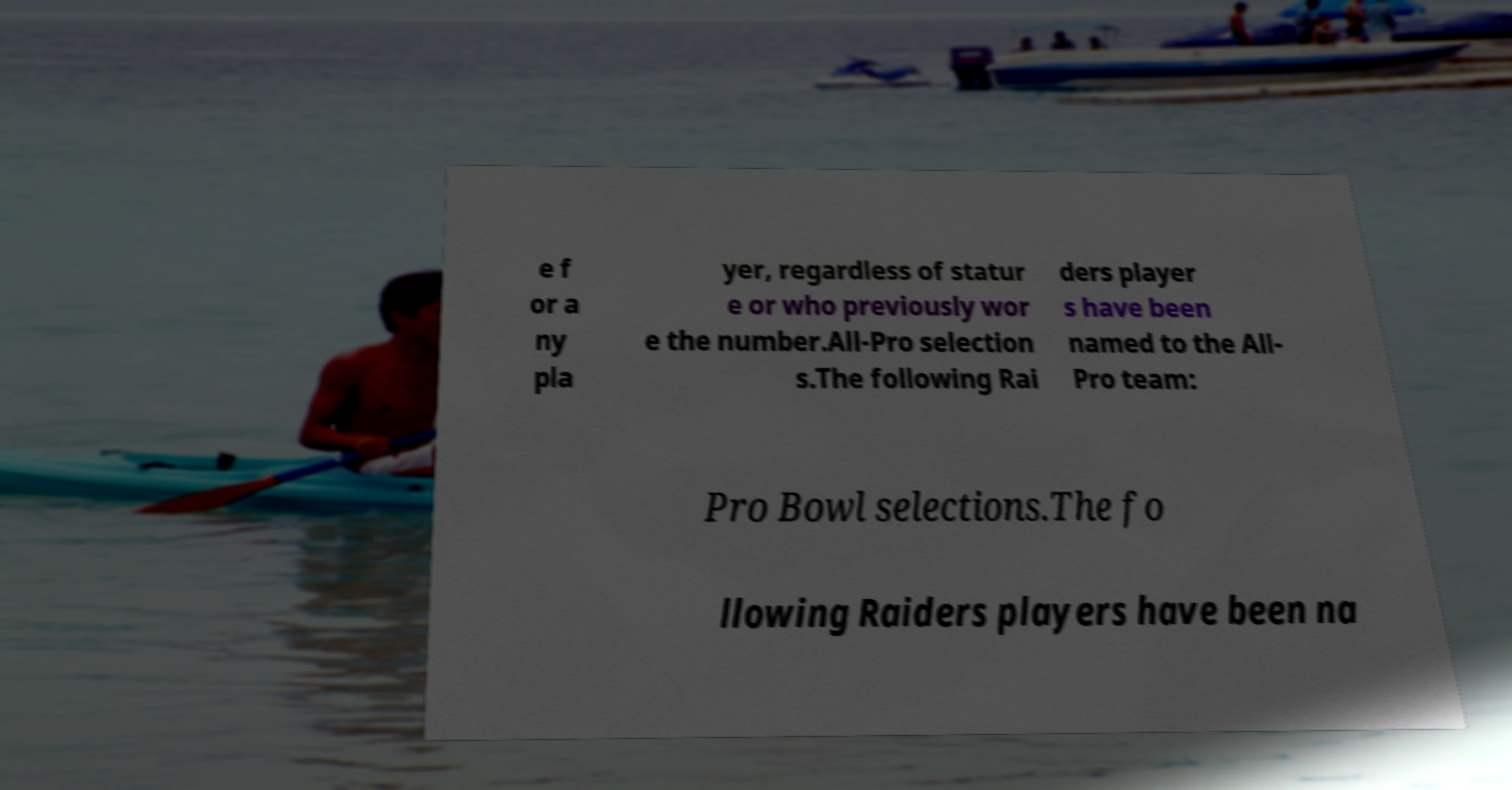Could you extract and type out the text from this image? e f or a ny pla yer, regardless of statur e or who previously wor e the number.All-Pro selection s.The following Rai ders player s have been named to the All- Pro team: Pro Bowl selections.The fo llowing Raiders players have been na 